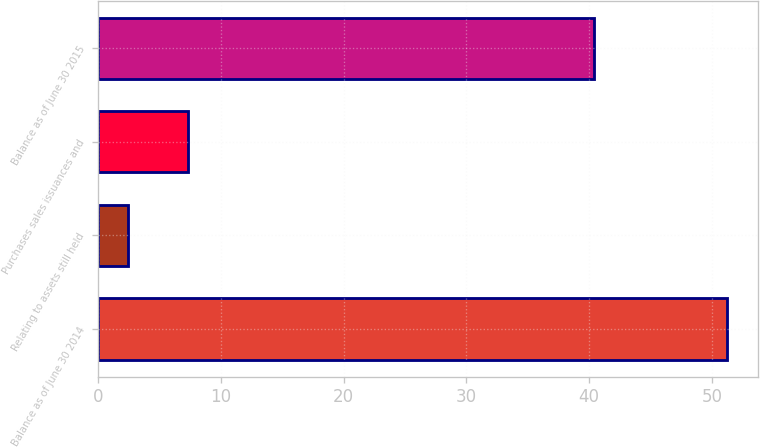<chart> <loc_0><loc_0><loc_500><loc_500><bar_chart><fcel>Balance as of June 30 2014<fcel>Relating to assets still held<fcel>Purchases sales issuances and<fcel>Balance as of June 30 2015<nl><fcel>51.2<fcel>2.4<fcel>7.28<fcel>40.4<nl></chart> 